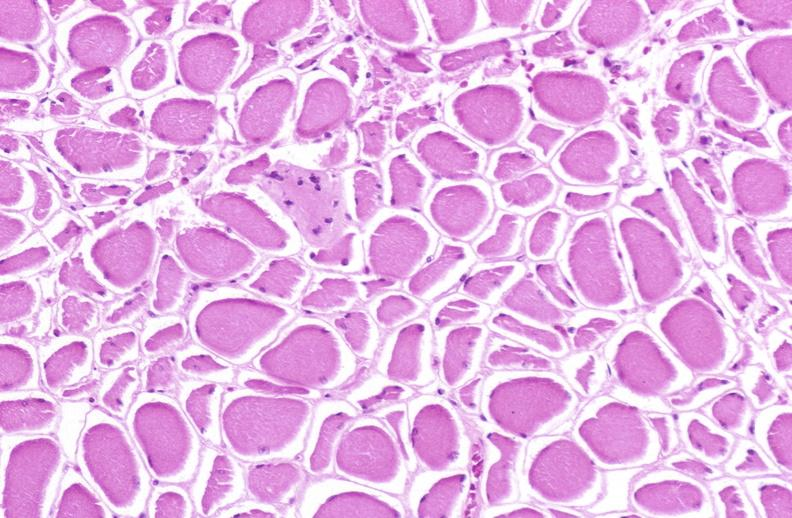does this image show skeletal muscle atrophy?
Answer the question using a single word or phrase. Yes 